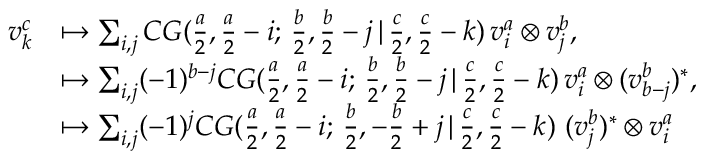Convert formula to latex. <formula><loc_0><loc_0><loc_500><loc_500>\begin{array} { r l } { v _ { k } ^ { c } } & { \mapsto \sum _ { i , j } C G ( \frac { a } { 2 } , \frac { a } { 2 } - i ; \, \frac { b } { 2 } , \frac { b } { 2 } - j \, | \, \frac { c } { 2 } , \frac { c } { 2 } - k ) \, v _ { i } ^ { a } \otimes v _ { j } ^ { b } , } \\ & { \mapsto \sum _ { i , j } ( - 1 ) ^ { b - j } C G ( \frac { a } { 2 } , \frac { a } { 2 } - i ; \, \frac { b } { 2 } , \frac { b } { 2 } - j \, | \, \frac { c } { 2 } , \frac { c } { 2 } - k ) \, v _ { i } ^ { a } \otimes ( v _ { b - j } ^ { b } ) ^ { * } , } \\ & { \mapsto \sum _ { i , j } ( - 1 ) ^ { j } C G ( \frac { a } { 2 } , \frac { a } { 2 } - i ; \, \frac { b } { 2 } , - \frac { b } { 2 } + j \, | \, \frac { c } { 2 } , \frac { c } { 2 } - k ) \, ( v _ { j } ^ { b } ) ^ { * } \otimes v _ { i } ^ { a } } \end{array}</formula> 